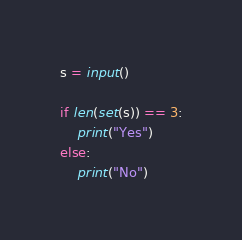Convert code to text. <code><loc_0><loc_0><loc_500><loc_500><_Python_>s = input()

if len(set(s)) == 3:
    print("Yes")
else:
    print("No")</code> 